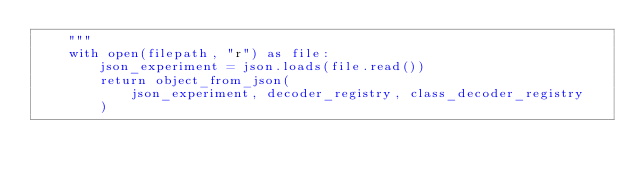Convert code to text. <code><loc_0><loc_0><loc_500><loc_500><_Python_>    """
    with open(filepath, "r") as file:
        json_experiment = json.loads(file.read())
        return object_from_json(
            json_experiment, decoder_registry, class_decoder_registry
        )
</code> 